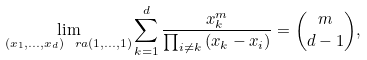Convert formula to latex. <formula><loc_0><loc_0><loc_500><loc_500>\lim _ { ( x _ { 1 } , \dots , x _ { d } ) \ r a ( 1 , \dots , 1 ) } { \sum _ { k = 1 } ^ { d } { \frac { x _ { k } ^ { m } } { \prod _ { i \neq k } { ( x _ { k } - x _ { i } ) } } } } = \binom { m } { d - 1 } ,</formula> 